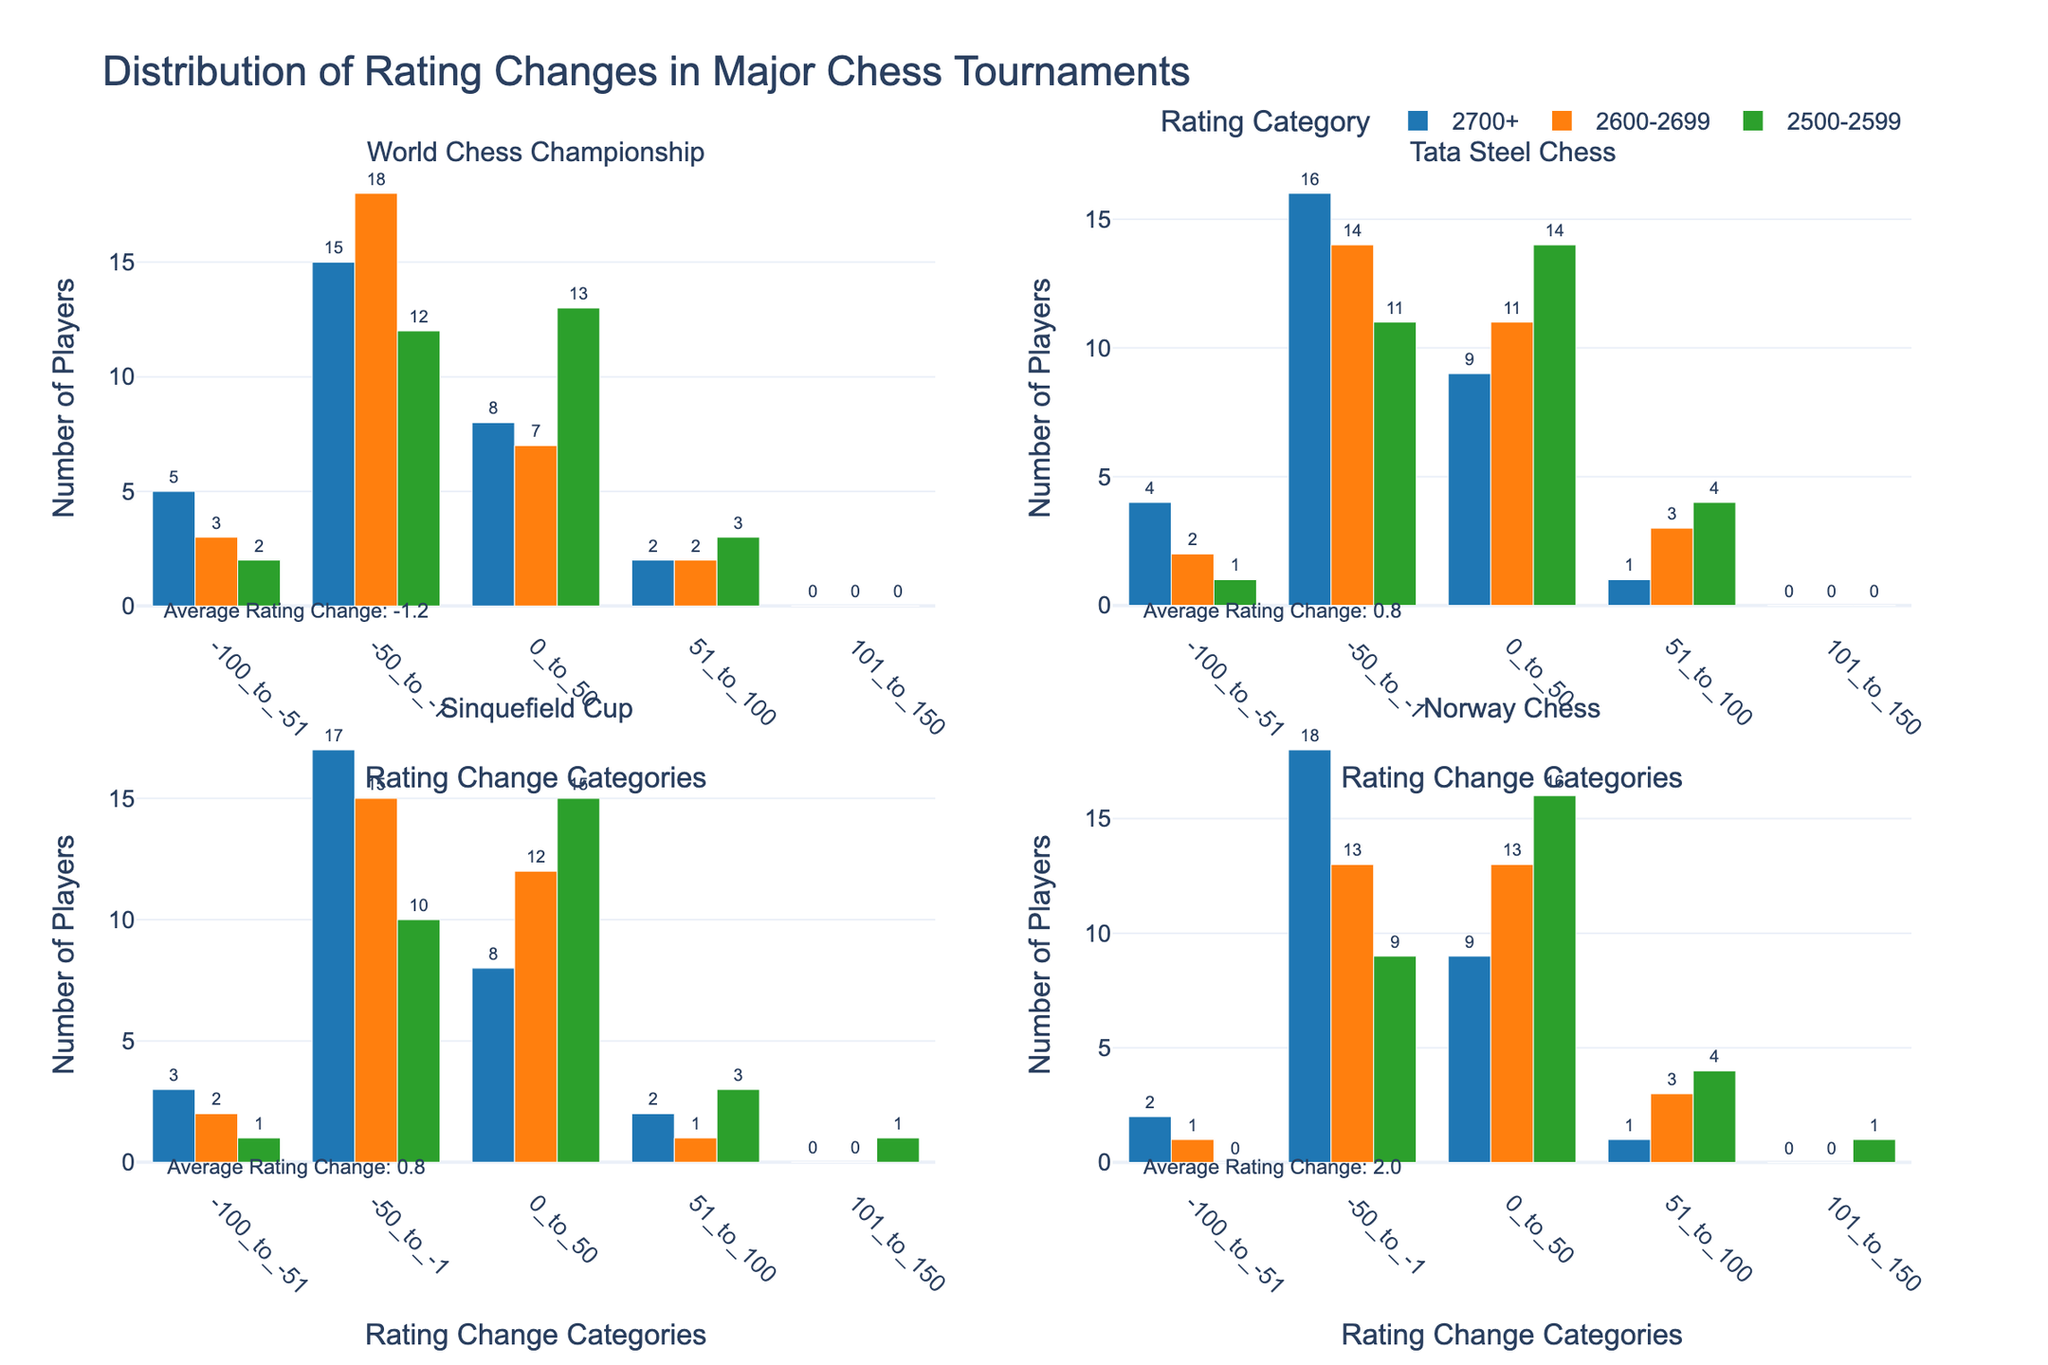What is the title of the figure? The title of the figure is displayed at the top center and provides an overview context of the visualized data.
Answer: Distribution of Rating Changes in Major Chess Tournaments How many subplots are there? The figure is divided into grids of subplots, with each subplot representing one of the major chess tournaments. You can count the number of distinct sections.
Answer: 4 Which rating category has the highest number of players with a rating change between 51 and 100 in the Norway Chess tournament? Look at the subplot for the Norway Chess tournament and compare the bars corresponding to the "51_to_100" category for each rating category. Identify the highest one.
Answer: 2500-2599 What is the average rating change for the World Chess Championship? The figure includes an annotation showing the average rating change for each tournament below the x-axis of the respective subplot. Read this value directly.
Answer: -1.8 How many players in the 2700+ rating category had a rating change between -50 to -1 in the Tata Steel Chess tournament? Find the subplot for the Tata Steel Chess tournament and locate the bar for the 2700+ rating category within the -50_to_-1 column. Read the value directly.
Answer: 16 Which tournament has the highest average rating change? Examine the annotations indicating the average rating changes below each subplot. Compare these values to determine the highest one.
Answer: Norway Chess In the Sinquefield Cup tournament, which two rating categories have the same number of players with a rating change between -50 to -1? Look at the subplot for the Sinquefield Cup, identify the bars under the -50_to_-1 category, and compare the values. Determine which two rating categories share the same number of players.
Answer: 2600-2699, 2500-2599 Which rating category shows the most significant improvement (positive rating change) across all tournaments? Scan across all subplots and rating change columns, focusing on the positive change categories (0 to 50, 51 to 100, etc.). Identify which rating category consistently has the highest values in these columns.
Answer: 2500-2599 